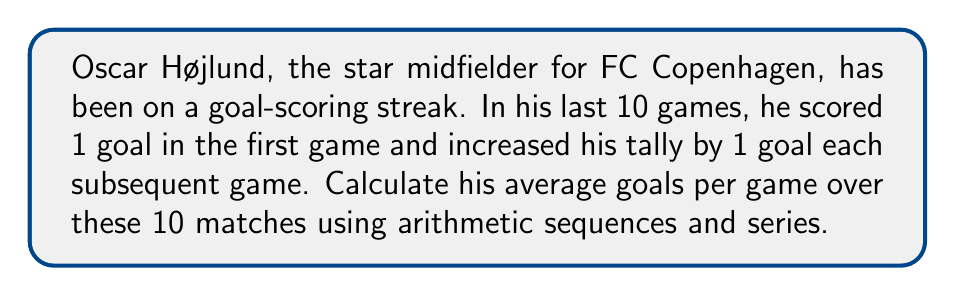Can you solve this math problem? Let's approach this step-by-step using arithmetic sequences and series:

1) First, we identify the arithmetic sequence:
   $a_1 = 1$ (first term)
   $d = 1$ (common difference)
   $n = 10$ (number of terms)

2) The last term of the sequence can be found using the formula:
   $a_n = a_1 + (n-1)d$
   $a_{10} = 1 + (10-1)1 = 10$

3) We can verify the sequence: 1, 2, 3, 4, 5, 6, 7, 8, 9, 10

4) To find the total number of goals, we need to sum this sequence. We can use the arithmetic series formula:

   $$S_n = \frac{n(a_1 + a_n)}{2}$$

   Where $S_n$ is the sum of the series, $n$ is the number of terms, $a_1$ is the first term, and $a_n$ is the last term.

5) Plugging in our values:

   $$S_{10} = \frac{10(1 + 10)}{2} = \frac{10(11)}{2} = 55$$

6) So, the total number of goals scored over 10 games is 55.

7) To find the average goals per game, we divide the total by the number of games:

   $$\text{Average} = \frac{\text{Total goals}}{\text{Number of games}} = \frac{55}{10} = 5.5$$

Therefore, Oscar Højlund's average goals per game over these 10 matches is 5.5 goals.
Answer: 5.5 goals per game 